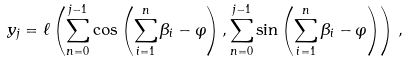<formula> <loc_0><loc_0><loc_500><loc_500>y _ { j } = \ell \left ( \sum _ { n = 0 } ^ { j - 1 } \cos \left ( \sum _ { i = 1 } ^ { n } \beta _ { i } - \varphi \right ) , \sum _ { n = 0 } ^ { j - 1 } \sin \left ( \sum _ { i = 1 } ^ { n } \beta _ { i } - \varphi \right ) \right ) \, ,</formula> 